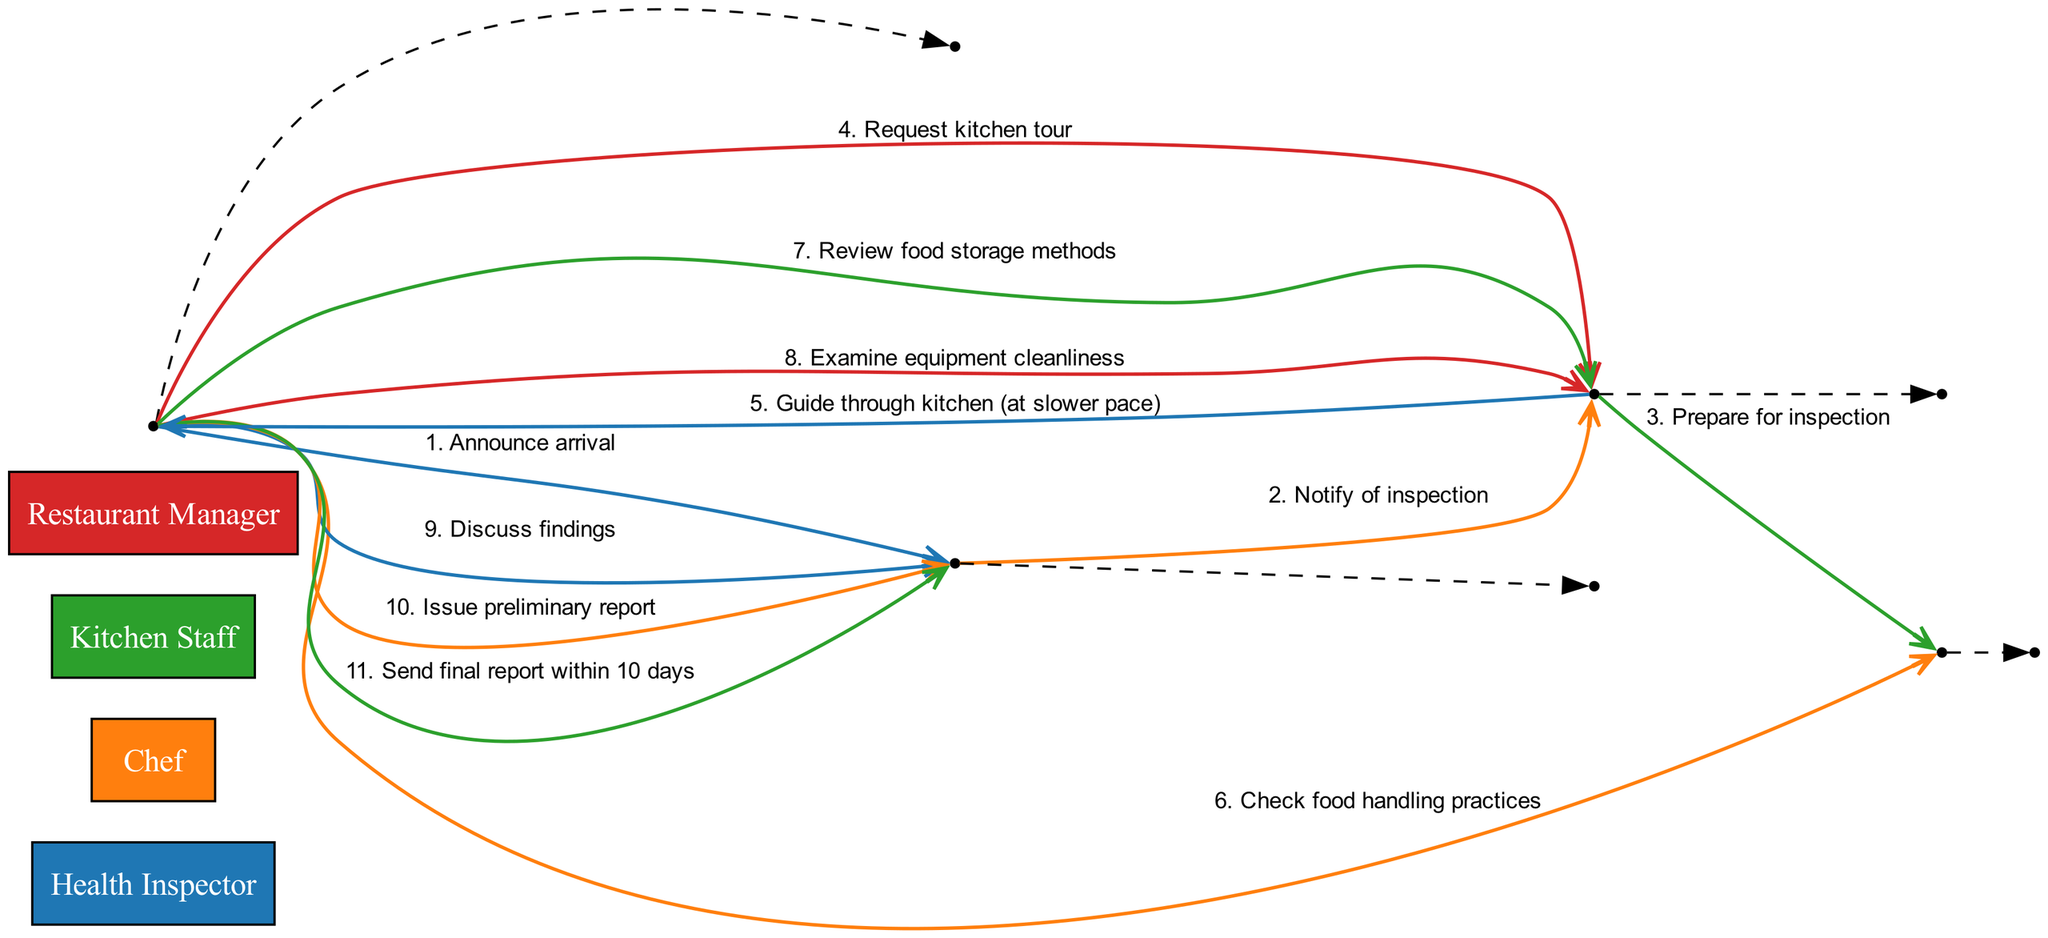What is the first message sent in the sequence? The first message occurs from the Health Inspector to the Restaurant Manager. It is labeled as "1. Announce arrival."
Answer: Announce arrival How many actors are involved in the inspection sequence? The diagram lists four distinct actors: Health Inspector, Chef, Kitchen Staff, and Restaurant Manager.
Answer: Four Which actor is responsible for guiding the Health Inspector through the kitchen? This responsibility is assigned to the Chef, who sends the message represented by "5. Guide through kitchen (at slower pace)."
Answer: Chef What is the last action taken in the sequence? The final message is sent from the Health Inspector to the Restaurant Manager, indicating "11. Send final report within 10 days."
Answer: Send final report within 10 days How many messages are exchanged between the Health Inspector and the Chef? The interactions between these two actors include three distinct messages: "4. Request kitchen tour," "7. Review food storage methods," and "8. Examine equipment cleanliness."
Answer: Three What does the Health Inspector discuss with the Restaurant Manager? The diagram shows that the Health Inspector discusses findings with the Restaurant Manager, as stated in "9. Discuss findings."
Answer: Findings Which two actors have the most direct interactions? The Health Inspector and the Chef directly interact multiple times throughout the sequence, indicating a close relationship in the inspection process.
Answer: Health Inspector and Chef What is the main focus of the Health Inspector's evaluation? The sequence includes specific actions such as checking food handling practices and reviewing food storage methods, indicating a primary focus on hygiene and safety practices.
Answer: Hygiene and safety practices 